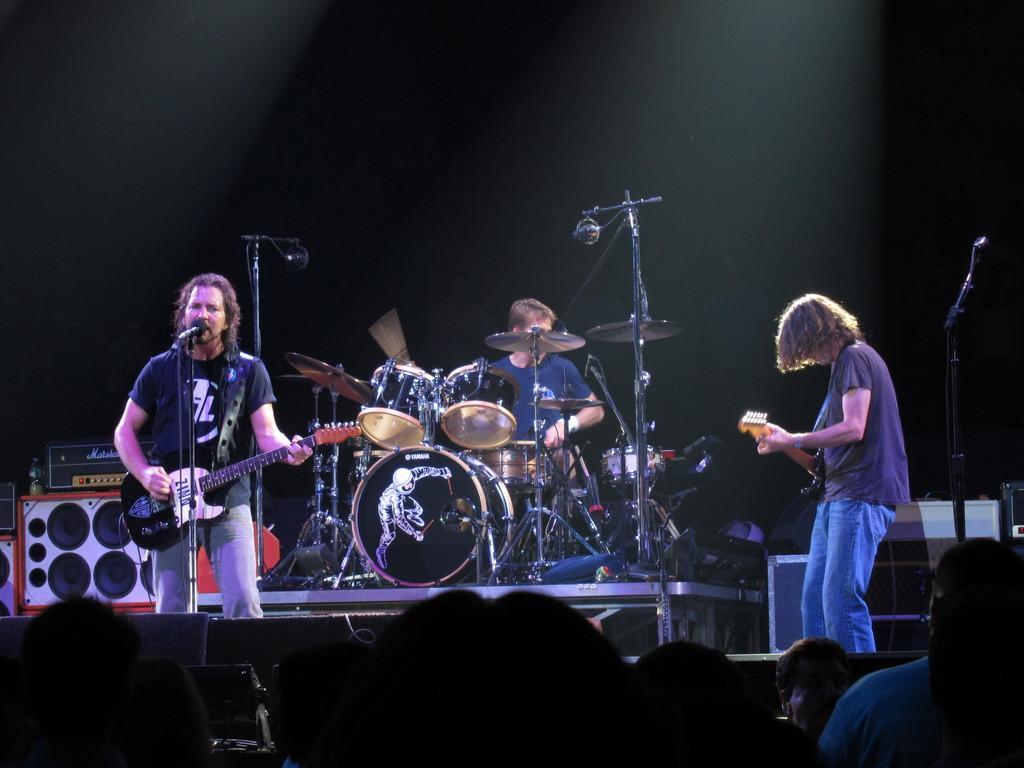Could you give a brief overview of what you see in this image? Here we can see two persons are playing guitar and he is singing on the mike. There is a man playing drums. These are some musical instruments. Here we can see some persons. 